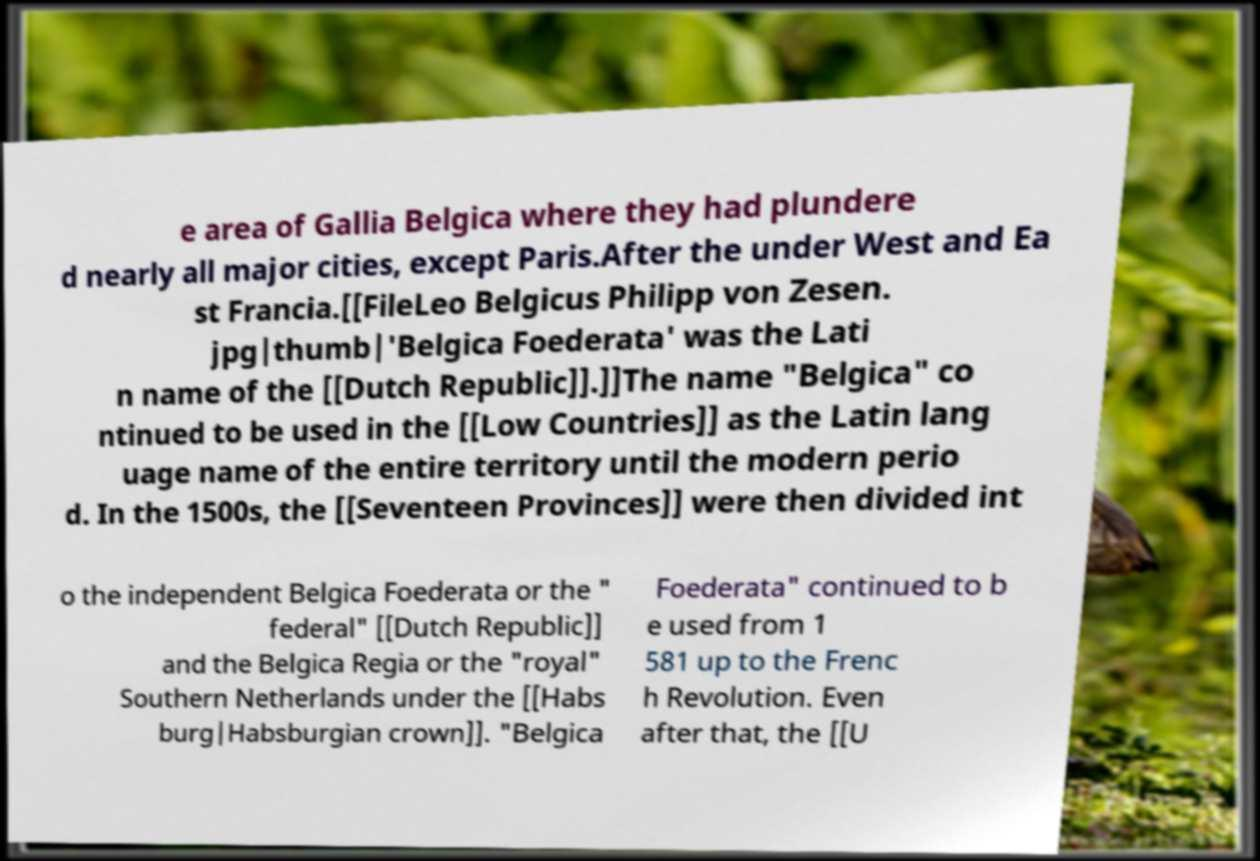What messages or text are displayed in this image? I need them in a readable, typed format. e area of Gallia Belgica where they had plundere d nearly all major cities, except Paris.After the under West and Ea st Francia.[[FileLeo Belgicus Philipp von Zesen. jpg|thumb|'Belgica Foederata' was the Lati n name of the [[Dutch Republic]].]]The name "Belgica" co ntinued to be used in the [[Low Countries]] as the Latin lang uage name of the entire territory until the modern perio d. In the 1500s, the [[Seventeen Provinces]] were then divided int o the independent Belgica Foederata or the " federal" [[Dutch Republic]] and the Belgica Regia or the "royal" Southern Netherlands under the [[Habs burg|Habsburgian crown]]. "Belgica Foederata" continued to b e used from 1 581 up to the Frenc h Revolution. Even after that, the [[U 